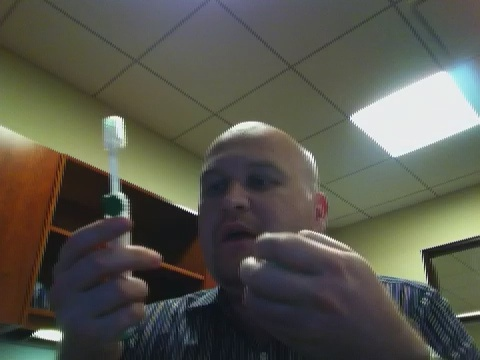Describe the objects in this image and their specific colors. I can see people in black and gray tones and toothbrush in black, darkgray, gray, and ivory tones in this image. 